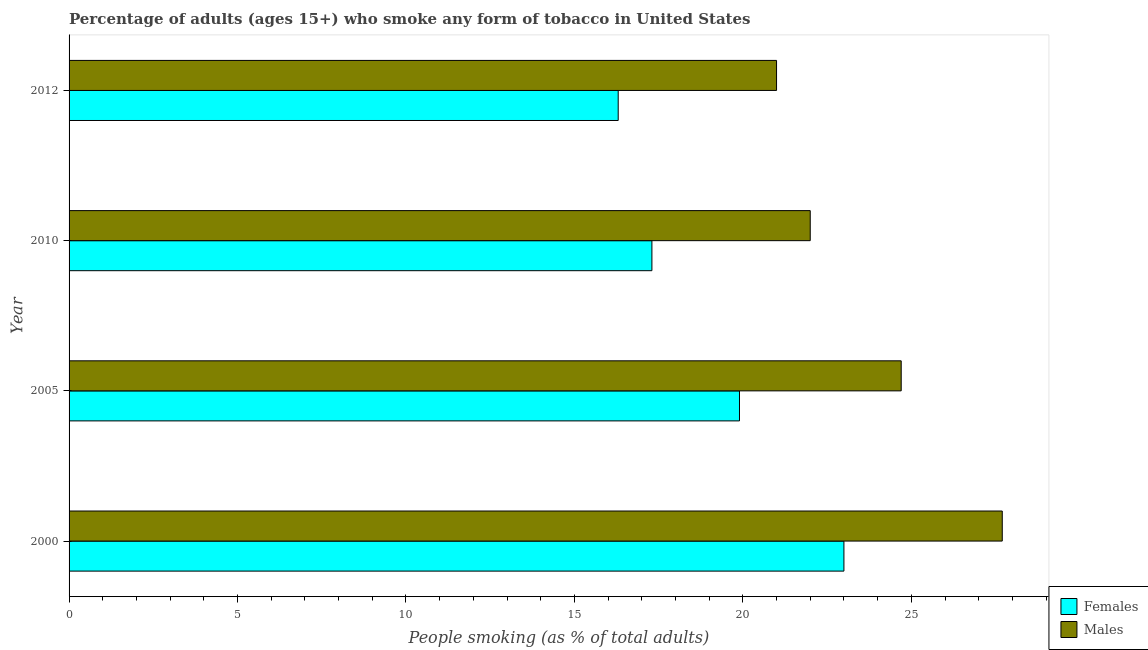How many different coloured bars are there?
Give a very brief answer. 2. How many groups of bars are there?
Keep it short and to the point. 4. Are the number of bars per tick equal to the number of legend labels?
Give a very brief answer. Yes. How many bars are there on the 4th tick from the top?
Provide a short and direct response. 2. In how many cases, is the number of bars for a given year not equal to the number of legend labels?
Offer a very short reply. 0. What is the percentage of males who smoke in 2012?
Keep it short and to the point. 21. Across all years, what is the maximum percentage of females who smoke?
Keep it short and to the point. 23. Across all years, what is the minimum percentage of males who smoke?
Keep it short and to the point. 21. In which year was the percentage of females who smoke maximum?
Your answer should be compact. 2000. In which year was the percentage of males who smoke minimum?
Offer a very short reply. 2012. What is the total percentage of females who smoke in the graph?
Make the answer very short. 76.5. What is the difference between the percentage of males who smoke in 2000 and the percentage of females who smoke in 2005?
Offer a very short reply. 7.8. What is the average percentage of males who smoke per year?
Your answer should be compact. 23.85. What is the ratio of the percentage of females who smoke in 2000 to that in 2010?
Give a very brief answer. 1.33. Is the percentage of males who smoke in 2000 less than that in 2010?
Give a very brief answer. No. What is the difference between the highest and the second highest percentage of females who smoke?
Your answer should be very brief. 3.1. In how many years, is the percentage of females who smoke greater than the average percentage of females who smoke taken over all years?
Your response must be concise. 2. Is the sum of the percentage of males who smoke in 2000 and 2010 greater than the maximum percentage of females who smoke across all years?
Offer a very short reply. Yes. What does the 1st bar from the top in 2012 represents?
Keep it short and to the point. Males. What does the 1st bar from the bottom in 2000 represents?
Your response must be concise. Females. How many bars are there?
Keep it short and to the point. 8. Are all the bars in the graph horizontal?
Provide a short and direct response. Yes. How many years are there in the graph?
Keep it short and to the point. 4. What is the difference between two consecutive major ticks on the X-axis?
Provide a succinct answer. 5. Does the graph contain any zero values?
Your answer should be very brief. No. Where does the legend appear in the graph?
Make the answer very short. Bottom right. What is the title of the graph?
Your answer should be very brief. Percentage of adults (ages 15+) who smoke any form of tobacco in United States. What is the label or title of the X-axis?
Your response must be concise. People smoking (as % of total adults). What is the label or title of the Y-axis?
Your answer should be very brief. Year. What is the People smoking (as % of total adults) in Females in 2000?
Give a very brief answer. 23. What is the People smoking (as % of total adults) of Males in 2000?
Make the answer very short. 27.7. What is the People smoking (as % of total adults) of Females in 2005?
Ensure brevity in your answer.  19.9. What is the People smoking (as % of total adults) in Males in 2005?
Keep it short and to the point. 24.7. What is the People smoking (as % of total adults) in Females in 2012?
Your answer should be very brief. 16.3. What is the People smoking (as % of total adults) in Males in 2012?
Ensure brevity in your answer.  21. Across all years, what is the maximum People smoking (as % of total adults) in Males?
Your answer should be compact. 27.7. Across all years, what is the minimum People smoking (as % of total adults) in Females?
Your answer should be very brief. 16.3. Across all years, what is the minimum People smoking (as % of total adults) in Males?
Keep it short and to the point. 21. What is the total People smoking (as % of total adults) in Females in the graph?
Your response must be concise. 76.5. What is the total People smoking (as % of total adults) in Males in the graph?
Offer a very short reply. 95.4. What is the difference between the People smoking (as % of total adults) of Males in 2000 and that in 2012?
Provide a short and direct response. 6.7. What is the difference between the People smoking (as % of total adults) in Females in 2010 and that in 2012?
Your answer should be compact. 1. What is the difference between the People smoking (as % of total adults) of Females in 2000 and the People smoking (as % of total adults) of Males in 2012?
Offer a terse response. 2. What is the difference between the People smoking (as % of total adults) in Females in 2010 and the People smoking (as % of total adults) in Males in 2012?
Ensure brevity in your answer.  -3.7. What is the average People smoking (as % of total adults) in Females per year?
Offer a very short reply. 19.12. What is the average People smoking (as % of total adults) in Males per year?
Your answer should be compact. 23.85. In the year 2005, what is the difference between the People smoking (as % of total adults) of Females and People smoking (as % of total adults) of Males?
Make the answer very short. -4.8. In the year 2010, what is the difference between the People smoking (as % of total adults) of Females and People smoking (as % of total adults) of Males?
Make the answer very short. -4.7. What is the ratio of the People smoking (as % of total adults) in Females in 2000 to that in 2005?
Provide a short and direct response. 1.16. What is the ratio of the People smoking (as % of total adults) of Males in 2000 to that in 2005?
Your response must be concise. 1.12. What is the ratio of the People smoking (as % of total adults) in Females in 2000 to that in 2010?
Make the answer very short. 1.33. What is the ratio of the People smoking (as % of total adults) of Males in 2000 to that in 2010?
Provide a succinct answer. 1.26. What is the ratio of the People smoking (as % of total adults) in Females in 2000 to that in 2012?
Your response must be concise. 1.41. What is the ratio of the People smoking (as % of total adults) of Males in 2000 to that in 2012?
Offer a very short reply. 1.32. What is the ratio of the People smoking (as % of total adults) in Females in 2005 to that in 2010?
Your answer should be very brief. 1.15. What is the ratio of the People smoking (as % of total adults) of Males in 2005 to that in 2010?
Provide a succinct answer. 1.12. What is the ratio of the People smoking (as % of total adults) of Females in 2005 to that in 2012?
Provide a short and direct response. 1.22. What is the ratio of the People smoking (as % of total adults) in Males in 2005 to that in 2012?
Your response must be concise. 1.18. What is the ratio of the People smoking (as % of total adults) in Females in 2010 to that in 2012?
Provide a short and direct response. 1.06. What is the ratio of the People smoking (as % of total adults) in Males in 2010 to that in 2012?
Offer a terse response. 1.05. What is the difference between the highest and the second highest People smoking (as % of total adults) of Females?
Offer a terse response. 3.1. What is the difference between the highest and the second highest People smoking (as % of total adults) of Males?
Keep it short and to the point. 3. What is the difference between the highest and the lowest People smoking (as % of total adults) of Females?
Your answer should be compact. 6.7. 